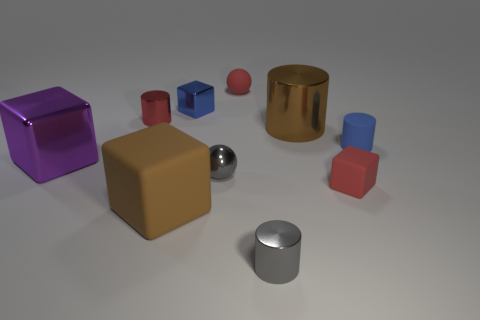Is the matte ball the same color as the small rubber block?
Your answer should be compact. Yes. Is the number of small matte things that are right of the tiny matte cylinder the same as the number of large brown things that are behind the big purple metal thing?
Keep it short and to the point. No. What color is the tiny metallic cylinder that is left of the small red matte thing that is behind the large purple shiny thing in front of the red matte sphere?
Offer a terse response. Red. Is there anything else of the same color as the large shiny block?
Make the answer very short. No. There is a rubber object that is the same color as the rubber ball; what shape is it?
Your answer should be compact. Cube. What is the size of the matte object behind the small red metallic object?
Offer a terse response. Small. There is a red rubber object that is the same size as the red cube; what shape is it?
Your answer should be very brief. Sphere. Is the material of the tiny red thing in front of the large metal cylinder the same as the tiny blue object in front of the red cylinder?
Offer a very short reply. Yes. What is the material of the small red cube that is in front of the small matte thing that is behind the brown cylinder?
Make the answer very short. Rubber. What size is the metallic block behind the blue thing right of the ball in front of the tiny blue matte cylinder?
Keep it short and to the point. Small. 